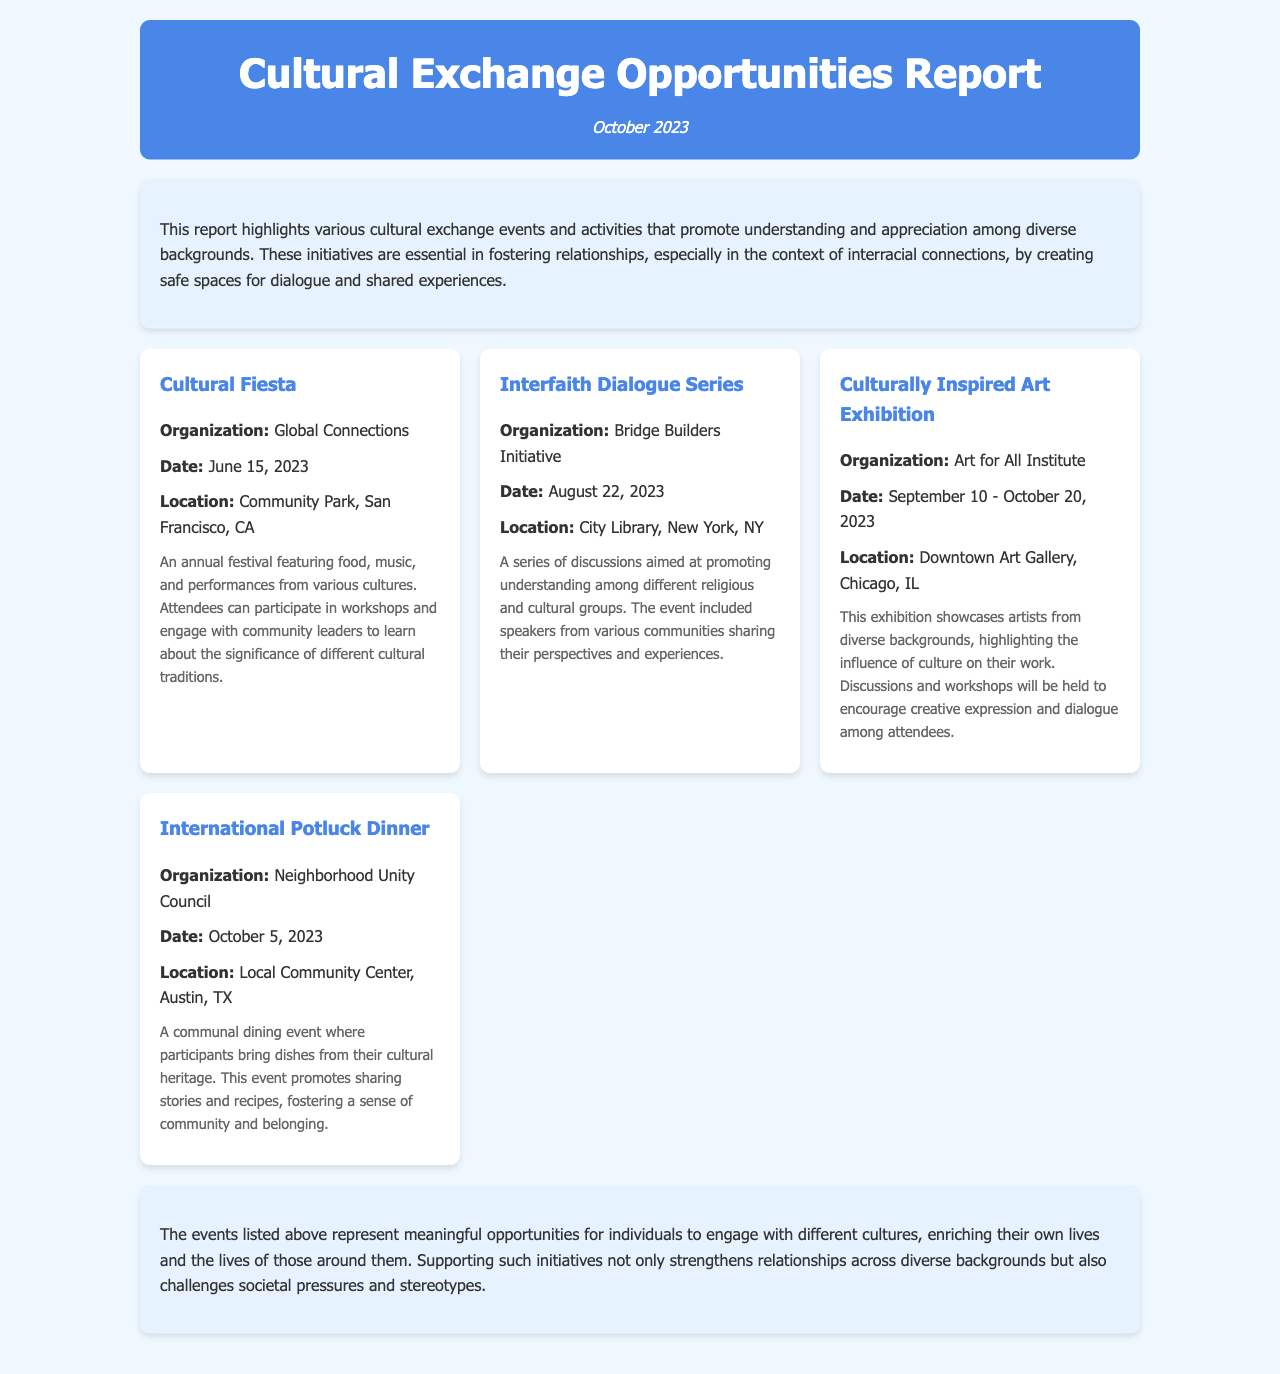What is the title of the report? The title is stated at the top of the document as "Cultural Exchange Opportunities Report."
Answer: Cultural Exchange Opportunities Report What is the date of the report? The date is mentioned in the header of the document as "October 2023."
Answer: October 2023 What organization is hosting the Cultural Fiesta? This information is specified in the event details for the Cultural Fiesta as "Global Connections."
Answer: Global Connections When does the Culturally Inspired Art Exhibition take place? The date range for the exhibition is clearly provided as "September 10 - October 20, 2023."
Answer: September 10 - October 20, 2023 What type of event is the International Potluck Dinner? The description states that it is a "communal dining event."
Answer: communal dining event How do the events contribute to relationships? The conclusion highlights that the events "strengthen relationships across diverse backgrounds."
Answer: strengthen relationships across diverse backgrounds What location is the Interfaith Dialogue Series held in? The document directly states that the location is "City Library, New York, NY."
Answer: City Library, New York, NY What overall purpose do the reported events serve? The introduction mentions that the events are essential for "promoting understanding and appreciation among diverse backgrounds."
Answer: promoting understanding and appreciation among diverse backgrounds Which event involves food from cultural heritages? The document specifies that the "International Potluck Dinner" involves this aspect.
Answer: International Potluck Dinner 